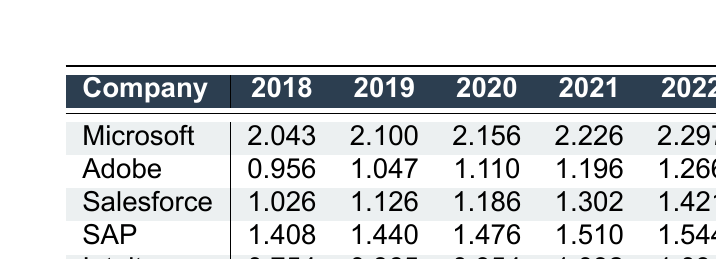What was the logarithmic revenue of Microsoft in 2021? The table shows that the logarithmic revenue for Microsoft in 2021 is listed directly in the row corresponding to Microsoft under the 2021 column. Looking at that cell, the value is 2.226.
Answer: 2.226 Which company had the highest logarithmic revenue in 2022? To identify the highest logarithmic revenue in 2022, we compare the values for all companies in that year: Microsoft (2.297), Adobe (1.266), Salesforce (1.421), SAP (1.544), and Intuit (1.094). The highest value is 2.297 for Microsoft.
Answer: Microsoft What is the average logarithmic revenue for Salesforce over the years? To find the average, we sum the logarithmic revenues for Salesforce from 2018 to 2022: 1.026 + 1.126 + 1.186 + 1.302 + 1.421 = 5.061. Then, we divide by the number of years, which is 5. So, 5.061 / 5 = 1.0122.
Answer: 1.0122 Did Adobe's logarithmic revenue increase every year from 2018 to 2022? We need to check the values for each year: 0.956 in 2018, 1.047 in 2019, 1.110 in 2020, 1.196 in 2021, and 1.266 in 2022. Since all values are increasing each year, the answer is yes.
Answer: Yes What is the difference in logarithmic revenue between SAP in 2018 and SAP in 2022? First, we look at the logarithmic revenue for SAP in 2018, which is 1.408, and in 2022, which is 1.544. To find the difference, we subtract the 2018 value from the 2022 value: 1.544 - 1.408 = 0.136.
Answer: 0.136 What was Intuit's logarithmic revenue in 2020? The table shows that the logarithmic revenue for Intuit in 2020 is directly listed in the row associated with Intuit under the 2020 column, which is 0.954.
Answer: 0.954 Which company had the lowest logarithmic revenue in 2018? By checking the values for the year 2018 across all companies: Microsoft (2.043), Adobe (0.956), Salesforce (1.026), SAP (1.408), and Intuit (0.754), we see that Intuit has the lowest value at 0.754.
Answer: Intuit What is the total logarithmic revenue for SAP over the last five years? We sum SAP's logarithmic revenues from 2018 to 2022: 1.408 + 1.440 + 1.476 + 1.510 + 1.544 = 7.378. This sum represents the total logarithmic revenue over those years.
Answer: 7.378 